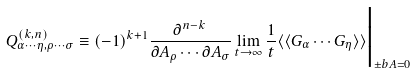Convert formula to latex. <formula><loc_0><loc_0><loc_500><loc_500>Q _ { \alpha \cdots \eta , \rho \cdots \sigma } ^ { ( k , n ) } \equiv ( - 1 ) ^ { k + 1 } \frac { \partial ^ { n - k } } { \partial A _ { \rho } \cdots \partial A _ { \sigma } } \lim _ { t \rightarrow \infty } \frac { 1 } { t } \langle \langle G _ { \alpha } \cdots G _ { \eta } \rangle \rangle \Big | _ { \pm b { A } = 0 }</formula> 